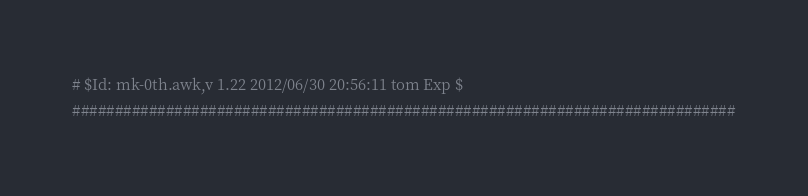<code> <loc_0><loc_0><loc_500><loc_500><_Awk_># $Id: mk-0th.awk,v 1.22 2012/06/30 20:56:11 tom Exp $
##############################################################################</code> 